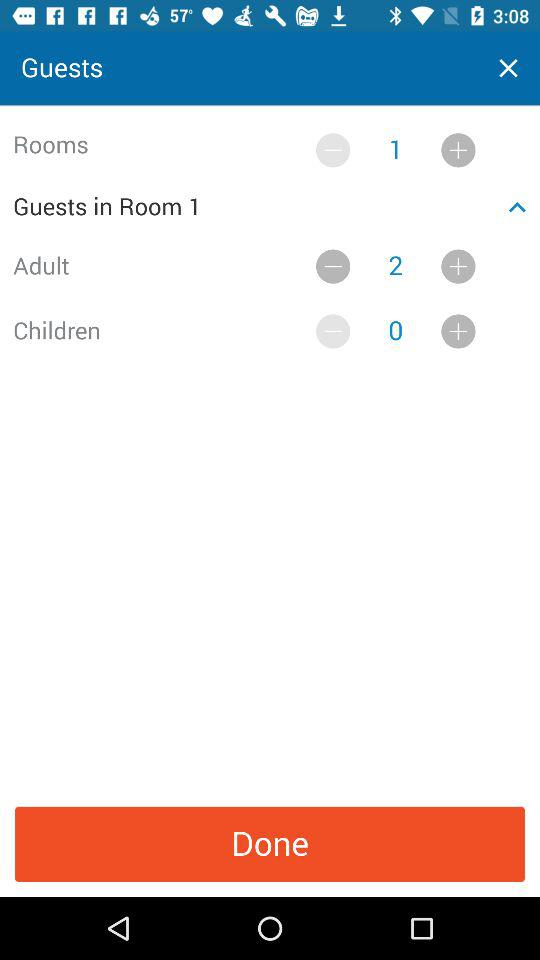How many rooms are selected? There is 1 selected room. 